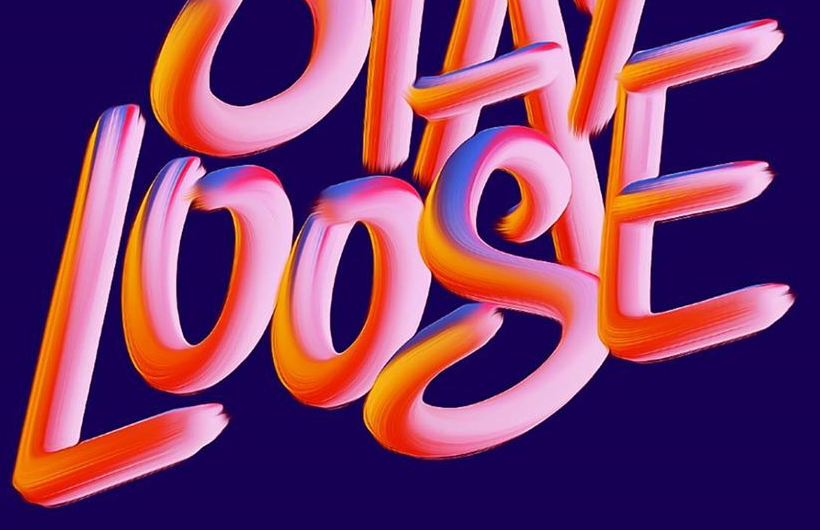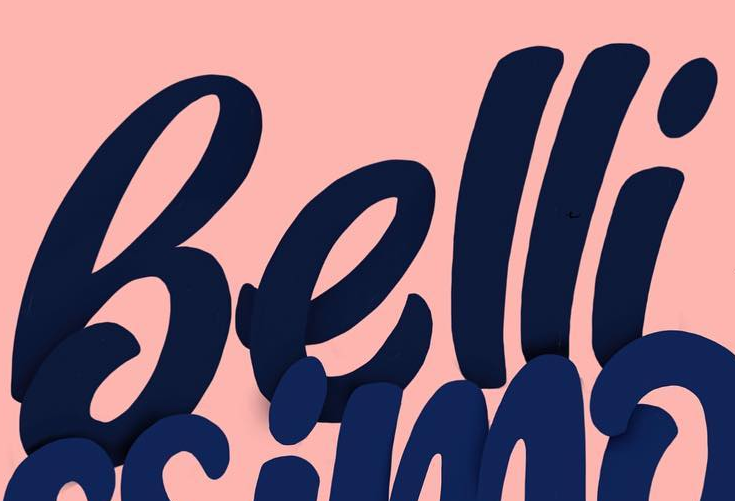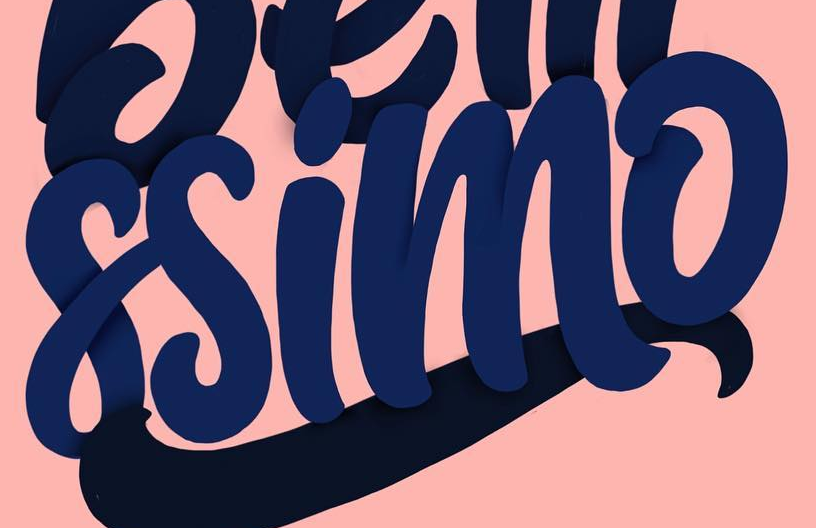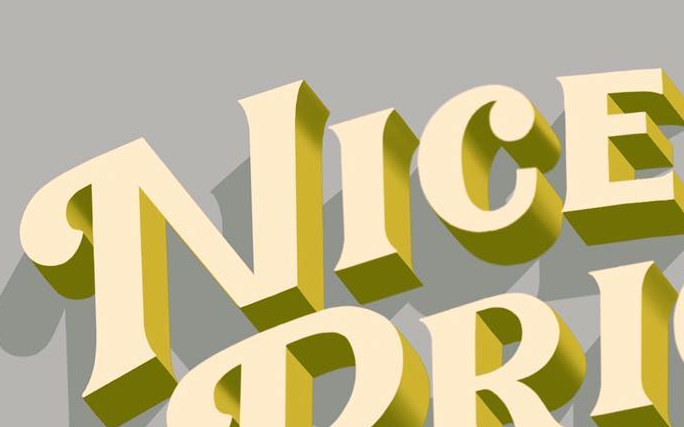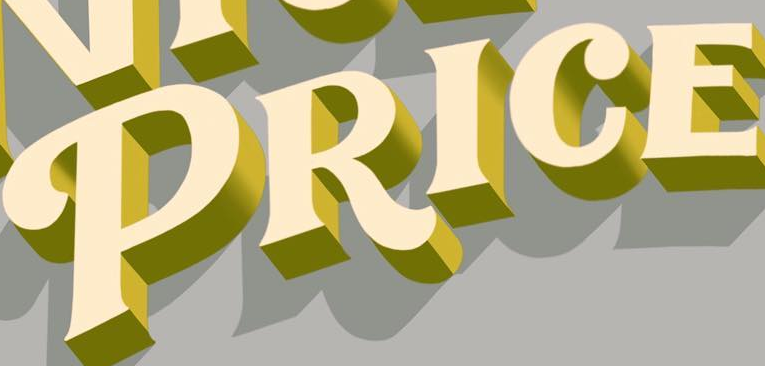What words can you see in these images in sequence, separated by a semicolon? LOOSE; Belli; ssimo; NICE; PRICE 